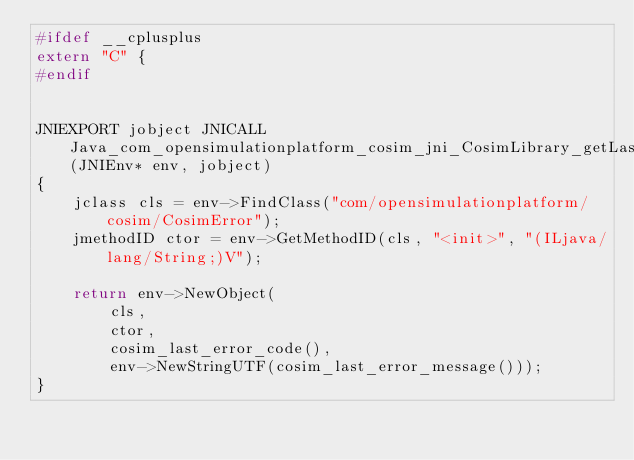<code> <loc_0><loc_0><loc_500><loc_500><_C++_>#ifdef __cplusplus
extern "C" {
#endif


JNIEXPORT jobject JNICALL Java_com_opensimulationplatform_cosim_jni_CosimLibrary_getLastError(JNIEnv* env, jobject)
{
    jclass cls = env->FindClass("com/opensimulationplatform/cosim/CosimError");
    jmethodID ctor = env->GetMethodID(cls, "<init>", "(ILjava/lang/String;)V");

    return env->NewObject(
        cls,
        ctor,
        cosim_last_error_code(),
        env->NewStringUTF(cosim_last_error_message()));
}
</code> 